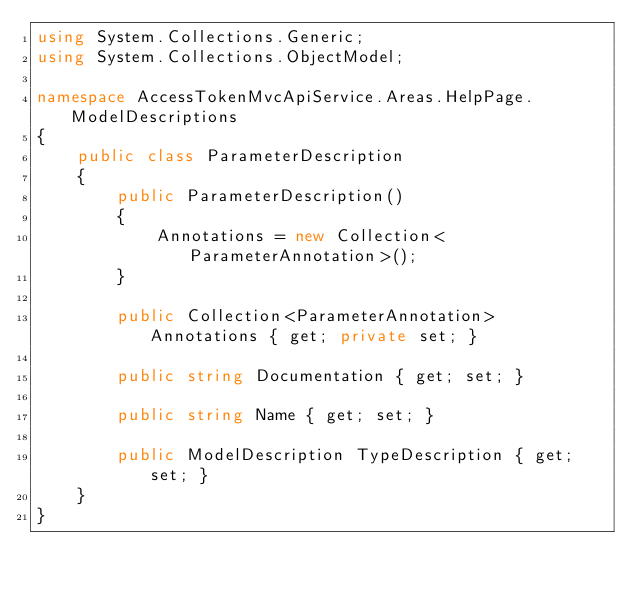<code> <loc_0><loc_0><loc_500><loc_500><_C#_>using System.Collections.Generic;
using System.Collections.ObjectModel;

namespace AccessTokenMvcApiService.Areas.HelpPage.ModelDescriptions
{
    public class ParameterDescription
    {
        public ParameterDescription()
        {
            Annotations = new Collection<ParameterAnnotation>();
        }

        public Collection<ParameterAnnotation> Annotations { get; private set; }

        public string Documentation { get; set; }

        public string Name { get; set; }

        public ModelDescription TypeDescription { get; set; }
    }
}</code> 